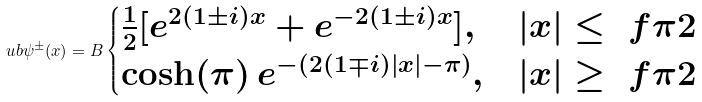Convert formula to latex. <formula><loc_0><loc_0><loc_500><loc_500>\ u b { \psi } ^ { \pm } ( x ) = B \begin{cases} \frac { 1 } { 2 } [ e ^ { 2 ( 1 \pm i ) x } + e ^ { - 2 ( 1 \pm i ) x } ] , & | x | \leq \ f { \pi } { 2 } \\ \cosh ( \pi ) \, e ^ { - ( 2 ( 1 \mp i ) | x | - \pi ) } , & | x | \geq \ f { \pi } { 2 } \end{cases}</formula> 